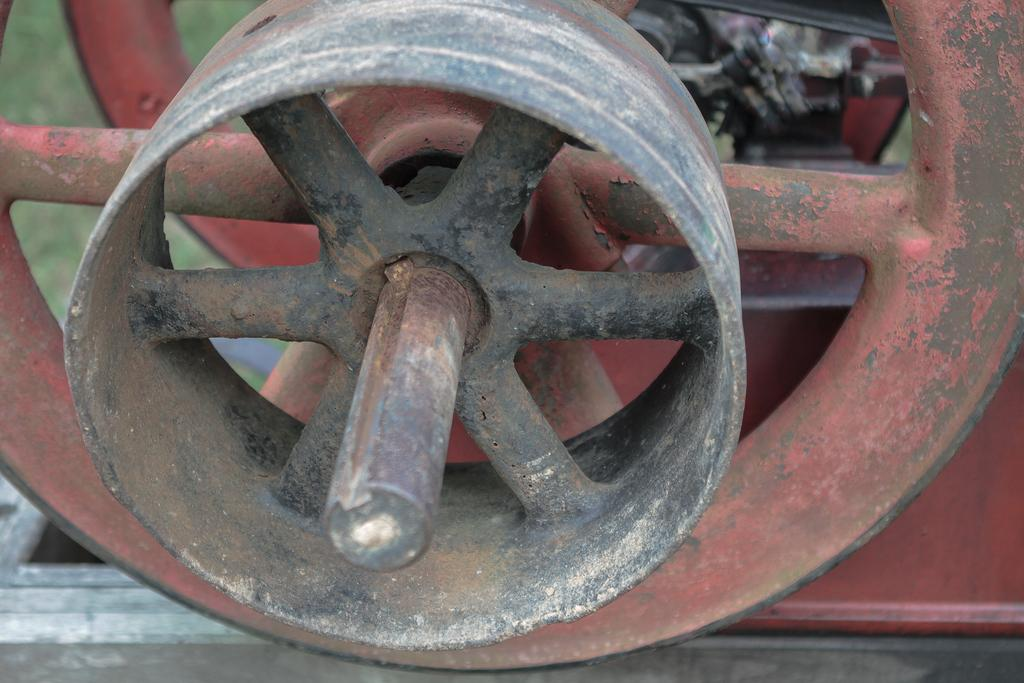What is the main subject in the center of the image? There is an object in the center of the image. What type of pain is being experienced by the loaf in the image? There is no loaf or indication of pain present in the image. 